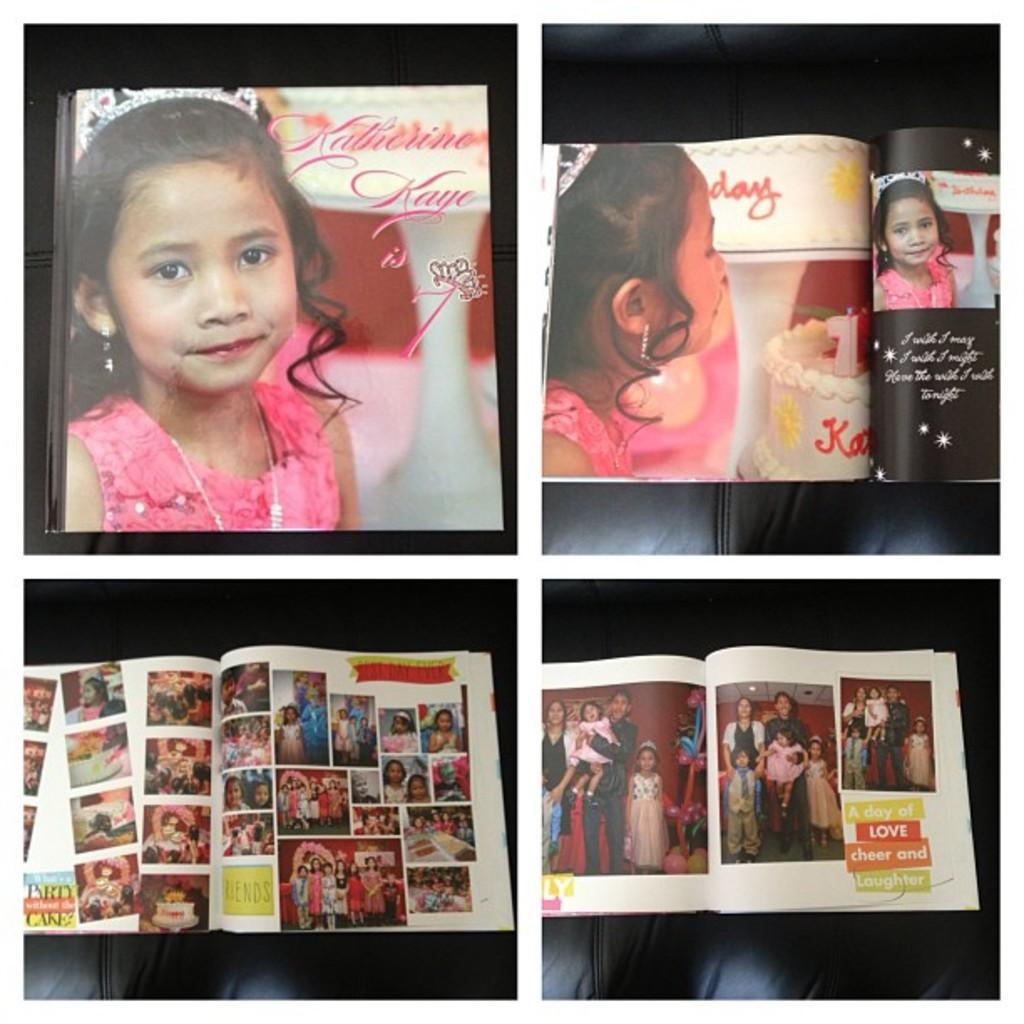What type of image is shown in the picture? The image is a collage. What is included in the collage? The collage consists of different photographs. What subject matter is depicted in the photographs? The photographs are of a girl. How many rocks can be seen in the collage? There are no rocks present in the collage; it consists of photographs of a girl. What type of boats are featured in the collage? There are no boats present in the collage; it consists of photographs of a girl. 